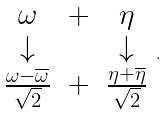<formula> <loc_0><loc_0><loc_500><loc_500>\begin{array} { c c c } \omega & + & \eta \\ \downarrow & & \downarrow \\ \frac { \omega - \overline { \omega } } { \sqrt { 2 } } & + & \frac { \eta + \overline { \eta } } { \sqrt { 2 } } \end{array} .</formula> 